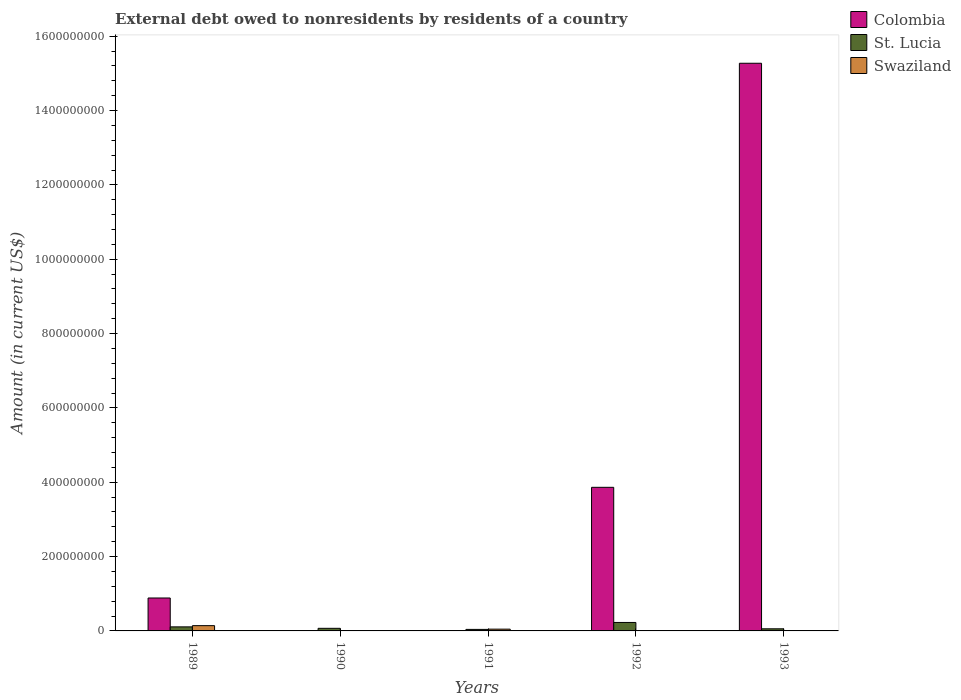How many different coloured bars are there?
Offer a very short reply. 3. Are the number of bars per tick equal to the number of legend labels?
Offer a terse response. No. How many bars are there on the 2nd tick from the left?
Offer a very short reply. 1. How many bars are there on the 2nd tick from the right?
Ensure brevity in your answer.  2. What is the external debt owed by residents in Colombia in 1992?
Provide a succinct answer. 3.86e+08. Across all years, what is the maximum external debt owed by residents in Swaziland?
Your answer should be compact. 1.42e+07. What is the total external debt owed by residents in Swaziland in the graph?
Make the answer very short. 1.90e+07. What is the difference between the external debt owed by residents in St. Lucia in 1990 and that in 1992?
Ensure brevity in your answer.  -1.58e+07. What is the difference between the external debt owed by residents in St. Lucia in 1989 and the external debt owed by residents in Colombia in 1991?
Ensure brevity in your answer.  1.09e+07. What is the average external debt owed by residents in St. Lucia per year?
Offer a terse response. 1.01e+07. In the year 1989, what is the difference between the external debt owed by residents in Swaziland and external debt owed by residents in St. Lucia?
Provide a short and direct response. 3.29e+06. What is the ratio of the external debt owed by residents in St. Lucia in 1989 to that in 1993?
Provide a short and direct response. 1.91. Is the external debt owed by residents in St. Lucia in 1991 less than that in 1992?
Your answer should be very brief. Yes. What is the difference between the highest and the second highest external debt owed by residents in Colombia?
Your answer should be compact. 1.14e+09. What is the difference between the highest and the lowest external debt owed by residents in St. Lucia?
Offer a terse response. 1.87e+07. In how many years, is the external debt owed by residents in Swaziland greater than the average external debt owed by residents in Swaziland taken over all years?
Provide a succinct answer. 2. How many bars are there?
Provide a succinct answer. 10. How many years are there in the graph?
Your response must be concise. 5. Are the values on the major ticks of Y-axis written in scientific E-notation?
Offer a terse response. No. Does the graph contain any zero values?
Offer a terse response. Yes. Does the graph contain grids?
Offer a very short reply. No. How many legend labels are there?
Make the answer very short. 3. How are the legend labels stacked?
Your response must be concise. Vertical. What is the title of the graph?
Ensure brevity in your answer.  External debt owed to nonresidents by residents of a country. What is the label or title of the Y-axis?
Give a very brief answer. Amount (in current US$). What is the Amount (in current US$) in Colombia in 1989?
Your answer should be very brief. 8.86e+07. What is the Amount (in current US$) of St. Lucia in 1989?
Make the answer very short. 1.09e+07. What is the Amount (in current US$) of Swaziland in 1989?
Keep it short and to the point. 1.42e+07. What is the Amount (in current US$) of Colombia in 1990?
Your answer should be very brief. 0. What is the Amount (in current US$) in St. Lucia in 1990?
Offer a very short reply. 6.98e+06. What is the Amount (in current US$) of Swaziland in 1990?
Provide a succinct answer. 0. What is the Amount (in current US$) in Colombia in 1991?
Your response must be concise. 0. What is the Amount (in current US$) of St. Lucia in 1991?
Ensure brevity in your answer.  4.08e+06. What is the Amount (in current US$) of Swaziland in 1991?
Offer a terse response. 4.76e+06. What is the Amount (in current US$) in Colombia in 1992?
Provide a succinct answer. 3.86e+08. What is the Amount (in current US$) in St. Lucia in 1992?
Provide a short and direct response. 2.28e+07. What is the Amount (in current US$) in Colombia in 1993?
Your answer should be very brief. 1.53e+09. What is the Amount (in current US$) of St. Lucia in 1993?
Make the answer very short. 5.71e+06. What is the Amount (in current US$) in Swaziland in 1993?
Keep it short and to the point. 0. Across all years, what is the maximum Amount (in current US$) in Colombia?
Your response must be concise. 1.53e+09. Across all years, what is the maximum Amount (in current US$) of St. Lucia?
Provide a short and direct response. 2.28e+07. Across all years, what is the maximum Amount (in current US$) in Swaziland?
Provide a short and direct response. 1.42e+07. Across all years, what is the minimum Amount (in current US$) in St. Lucia?
Keep it short and to the point. 4.08e+06. Across all years, what is the minimum Amount (in current US$) of Swaziland?
Your response must be concise. 0. What is the total Amount (in current US$) in Colombia in the graph?
Give a very brief answer. 2.00e+09. What is the total Amount (in current US$) in St. Lucia in the graph?
Your answer should be compact. 5.05e+07. What is the total Amount (in current US$) of Swaziland in the graph?
Your answer should be very brief. 1.90e+07. What is the difference between the Amount (in current US$) in St. Lucia in 1989 and that in 1990?
Ensure brevity in your answer.  3.92e+06. What is the difference between the Amount (in current US$) of St. Lucia in 1989 and that in 1991?
Provide a succinct answer. 6.82e+06. What is the difference between the Amount (in current US$) of Swaziland in 1989 and that in 1991?
Give a very brief answer. 9.44e+06. What is the difference between the Amount (in current US$) in Colombia in 1989 and that in 1992?
Make the answer very short. -2.98e+08. What is the difference between the Amount (in current US$) of St. Lucia in 1989 and that in 1992?
Ensure brevity in your answer.  -1.19e+07. What is the difference between the Amount (in current US$) of Colombia in 1989 and that in 1993?
Offer a very short reply. -1.44e+09. What is the difference between the Amount (in current US$) in St. Lucia in 1989 and that in 1993?
Provide a short and direct response. 5.19e+06. What is the difference between the Amount (in current US$) of St. Lucia in 1990 and that in 1991?
Make the answer very short. 2.90e+06. What is the difference between the Amount (in current US$) of St. Lucia in 1990 and that in 1992?
Your response must be concise. -1.58e+07. What is the difference between the Amount (in current US$) of St. Lucia in 1990 and that in 1993?
Your response must be concise. 1.27e+06. What is the difference between the Amount (in current US$) of St. Lucia in 1991 and that in 1992?
Keep it short and to the point. -1.87e+07. What is the difference between the Amount (in current US$) in St. Lucia in 1991 and that in 1993?
Make the answer very short. -1.63e+06. What is the difference between the Amount (in current US$) in Colombia in 1992 and that in 1993?
Make the answer very short. -1.14e+09. What is the difference between the Amount (in current US$) of St. Lucia in 1992 and that in 1993?
Ensure brevity in your answer.  1.71e+07. What is the difference between the Amount (in current US$) in Colombia in 1989 and the Amount (in current US$) in St. Lucia in 1990?
Keep it short and to the point. 8.16e+07. What is the difference between the Amount (in current US$) in Colombia in 1989 and the Amount (in current US$) in St. Lucia in 1991?
Provide a succinct answer. 8.45e+07. What is the difference between the Amount (in current US$) of Colombia in 1989 and the Amount (in current US$) of Swaziland in 1991?
Ensure brevity in your answer.  8.38e+07. What is the difference between the Amount (in current US$) in St. Lucia in 1989 and the Amount (in current US$) in Swaziland in 1991?
Your response must be concise. 6.14e+06. What is the difference between the Amount (in current US$) in Colombia in 1989 and the Amount (in current US$) in St. Lucia in 1992?
Your answer should be compact. 6.58e+07. What is the difference between the Amount (in current US$) of Colombia in 1989 and the Amount (in current US$) of St. Lucia in 1993?
Make the answer very short. 8.29e+07. What is the difference between the Amount (in current US$) in St. Lucia in 1990 and the Amount (in current US$) in Swaziland in 1991?
Keep it short and to the point. 2.22e+06. What is the difference between the Amount (in current US$) in Colombia in 1992 and the Amount (in current US$) in St. Lucia in 1993?
Make the answer very short. 3.81e+08. What is the average Amount (in current US$) in Colombia per year?
Give a very brief answer. 4.00e+08. What is the average Amount (in current US$) in St. Lucia per year?
Offer a terse response. 1.01e+07. What is the average Amount (in current US$) of Swaziland per year?
Your answer should be very brief. 3.79e+06. In the year 1989, what is the difference between the Amount (in current US$) of Colombia and Amount (in current US$) of St. Lucia?
Provide a succinct answer. 7.77e+07. In the year 1989, what is the difference between the Amount (in current US$) in Colombia and Amount (in current US$) in Swaziland?
Ensure brevity in your answer.  7.44e+07. In the year 1989, what is the difference between the Amount (in current US$) in St. Lucia and Amount (in current US$) in Swaziland?
Your answer should be compact. -3.29e+06. In the year 1991, what is the difference between the Amount (in current US$) of St. Lucia and Amount (in current US$) of Swaziland?
Make the answer very short. -6.77e+05. In the year 1992, what is the difference between the Amount (in current US$) of Colombia and Amount (in current US$) of St. Lucia?
Ensure brevity in your answer.  3.64e+08. In the year 1993, what is the difference between the Amount (in current US$) in Colombia and Amount (in current US$) in St. Lucia?
Offer a terse response. 1.52e+09. What is the ratio of the Amount (in current US$) of St. Lucia in 1989 to that in 1990?
Keep it short and to the point. 1.56. What is the ratio of the Amount (in current US$) in St. Lucia in 1989 to that in 1991?
Your response must be concise. 2.67. What is the ratio of the Amount (in current US$) of Swaziland in 1989 to that in 1991?
Keep it short and to the point. 2.98. What is the ratio of the Amount (in current US$) of Colombia in 1989 to that in 1992?
Provide a succinct answer. 0.23. What is the ratio of the Amount (in current US$) in St. Lucia in 1989 to that in 1992?
Give a very brief answer. 0.48. What is the ratio of the Amount (in current US$) in Colombia in 1989 to that in 1993?
Your answer should be compact. 0.06. What is the ratio of the Amount (in current US$) of St. Lucia in 1989 to that in 1993?
Your answer should be very brief. 1.91. What is the ratio of the Amount (in current US$) in St. Lucia in 1990 to that in 1991?
Provide a succinct answer. 1.71. What is the ratio of the Amount (in current US$) in St. Lucia in 1990 to that in 1992?
Ensure brevity in your answer.  0.31. What is the ratio of the Amount (in current US$) in St. Lucia in 1990 to that in 1993?
Keep it short and to the point. 1.22. What is the ratio of the Amount (in current US$) in St. Lucia in 1991 to that in 1992?
Make the answer very short. 0.18. What is the ratio of the Amount (in current US$) of St. Lucia in 1991 to that in 1993?
Give a very brief answer. 0.72. What is the ratio of the Amount (in current US$) in Colombia in 1992 to that in 1993?
Provide a short and direct response. 0.25. What is the ratio of the Amount (in current US$) of St. Lucia in 1992 to that in 1993?
Your answer should be compact. 3.99. What is the difference between the highest and the second highest Amount (in current US$) of Colombia?
Ensure brevity in your answer.  1.14e+09. What is the difference between the highest and the second highest Amount (in current US$) in St. Lucia?
Offer a terse response. 1.19e+07. What is the difference between the highest and the lowest Amount (in current US$) in Colombia?
Your response must be concise. 1.53e+09. What is the difference between the highest and the lowest Amount (in current US$) of St. Lucia?
Your answer should be very brief. 1.87e+07. What is the difference between the highest and the lowest Amount (in current US$) of Swaziland?
Ensure brevity in your answer.  1.42e+07. 